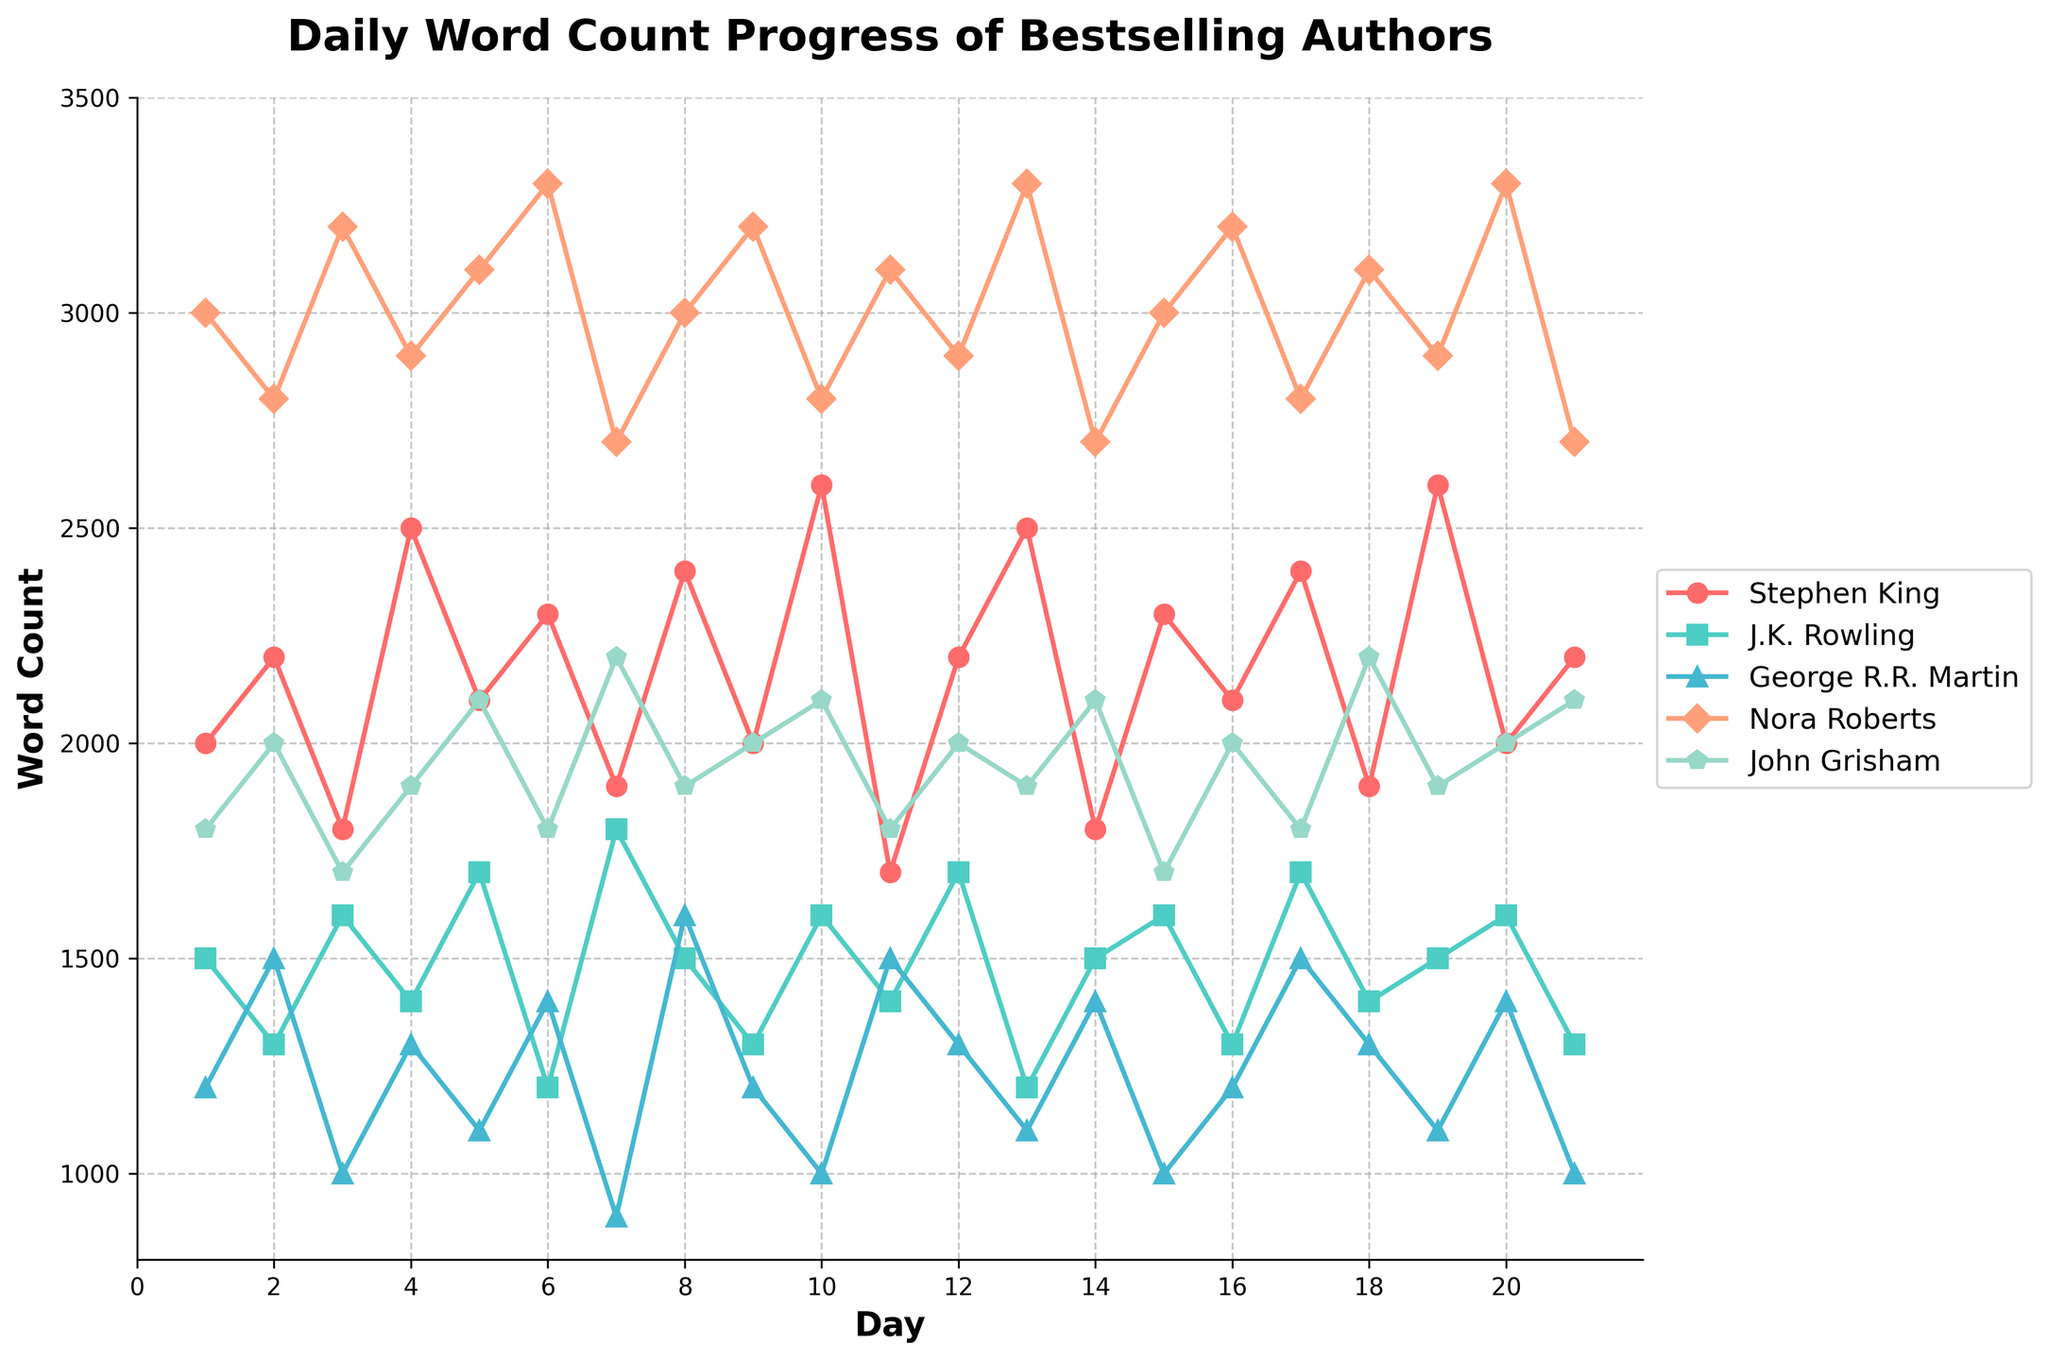What is the word count for Stephen King on Day 5? The word count for Stephen King on Day 5 is indicated by the point (5, 2100) on his line in the chart.
Answer: 2100 Which author had the highest word count on Day 10? On Day 10, the highest point on the chart corresponds to Nora Roberts with a word count of 2800.
Answer: Nora Roberts What is the average word count for George R.R. Martin over the first 5 days? The word counts for George R.R. Martin over the first 5 days are 1200, 1500, 1000, 1300, and 1100. Adding these gives 6100, then divide by 5 to get the average: (1200 + 1500 + 1000 + 1300 + 1100) / 5 = 1220.
Answer: 1220 Compare the word counts of J.K. Rowling and John Grisham on Day 2. Who wrote more words? On Day 2, J.K. Rowling's word count is 1300, and John Grisham's word count is 2000. John Grisham wrote more words.
Answer: John Grisham Which author's word count shows the most consistent upward trend? Nora Roberts’ word count consistently shows larger values and maintains a progressively high word count over the days compared to others, indicating an upward trend.
Answer: Nora Roberts On which day did Stephen King have his lowest word count, and what was it? Stephen King's lowest word count was on Day 11 with a count of 1700 as indicated by the lowest point on his line.
Answer: Day 11, 1700 What’s the sum of the word counts for J.K. Rowling and George R.R. Martin on Day 15? Adding the word counts of J.K. Rowling (1600) and George R.R. Martin (1000) on Day 15 gives: 1600 + 1000 = 2600.
Answer: 2600 How many times did John Grisham achieve a word count of 2100? John Grisham's word count reached exactly 2100 three times - on Days 5, 10, and 21, as observed from the matching points.
Answer: 3 What is the range of Nora Roberts' word counts over the depicted period? The range is found by subtracting the minimum value from the maximum value in Nora Roberts' word counts: Maximum (3300 on multiple days) - Minimum (2700 on Days 7, 14, and 21) = 3300 - 2700 = 600.
Answer: 600 Whose word count on Day 6 was lower, George R.R. Martin or John Grisham? On Day 6, George R.R. Martin's word count is 1400, while John Grisham's word count is 1800. George R.R. Martin’s word count is lower.
Answer: George R.R. Martin 